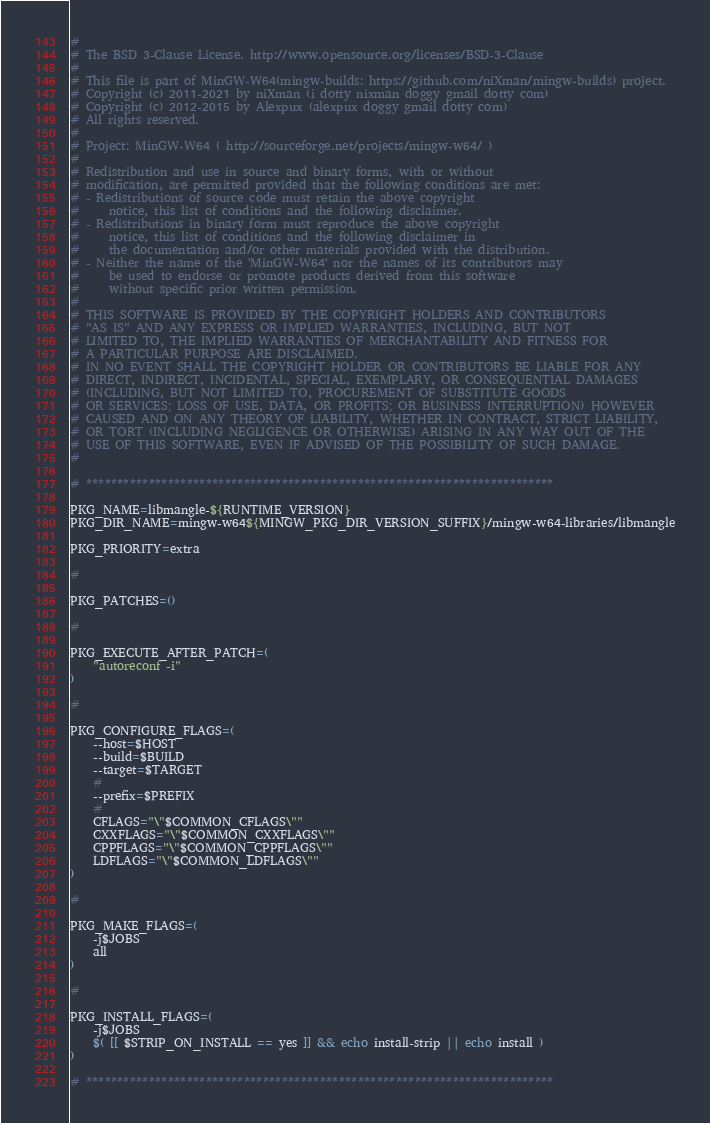Convert code to text. <code><loc_0><loc_0><loc_500><loc_500><_Bash_>
#
# The BSD 3-Clause License. http://www.opensource.org/licenses/BSD-3-Clause
#
# This file is part of MinGW-W64(mingw-builds: https://github.com/niXman/mingw-builds) project.
# Copyright (c) 2011-2021 by niXman (i dotty nixman doggy gmail dotty com)
# Copyright (c) 2012-2015 by Alexpux (alexpux doggy gmail dotty com)
# All rights reserved.
#
# Project: MinGW-W64 ( http://sourceforge.net/projects/mingw-w64/ )
#
# Redistribution and use in source and binary forms, with or without
# modification, are permitted provided that the following conditions are met:
# - Redistributions of source code must retain the above copyright
#     notice, this list of conditions and the following disclaimer.
# - Redistributions in binary form must reproduce the above copyright
#     notice, this list of conditions and the following disclaimer in
#     the documentation and/or other materials provided with the distribution.
# - Neither the name of the 'MinGW-W64' nor the names of its contributors may
#     be used to endorse or promote products derived from this software
#     without specific prior written permission.
#
# THIS SOFTWARE IS PROVIDED BY THE COPYRIGHT HOLDERS AND CONTRIBUTORS
# "AS IS" AND ANY EXPRESS OR IMPLIED WARRANTIES, INCLUDING, BUT NOT
# LIMITED TO, THE IMPLIED WARRANTIES OF MERCHANTABILITY AND FITNESS FOR
# A PARTICULAR PURPOSE ARE DISCLAIMED.
# IN NO EVENT SHALL THE COPYRIGHT HOLDER OR CONTRIBUTORS BE LIABLE FOR ANY
# DIRECT, INDIRECT, INCIDENTAL, SPECIAL, EXEMPLARY, OR CONSEQUENTIAL DAMAGES
# (INCLUDING, BUT NOT LIMITED TO, PROCUREMENT OF SUBSTITUTE GOODS
# OR SERVICES; LOSS OF USE, DATA, OR PROFITS; OR BUSINESS INTERRUPTION) HOWEVER
# CAUSED AND ON ANY THEORY OF LIABILITY, WHETHER IN CONTRACT, STRICT LIABILITY,
# OR TORT (INCLUDING NEGLIGENCE OR OTHERWISE) ARISING IN ANY WAY OUT OF THE
# USE OF THIS SOFTWARE, EVEN IF ADVISED OF THE POSSIBILITY OF SUCH DAMAGE.
#

# **************************************************************************

PKG_NAME=libmangle-${RUNTIME_VERSION}
PKG_DIR_NAME=mingw-w64${MINGW_PKG_DIR_VERSION_SUFFIX}/mingw-w64-libraries/libmangle

PKG_PRIORITY=extra

#

PKG_PATCHES=()

#

PKG_EXECUTE_AFTER_PATCH=(
	"autoreconf -i"
)

#

PKG_CONFIGURE_FLAGS=(
	--host=$HOST
	--build=$BUILD
	--target=$TARGET
	#
	--prefix=$PREFIX
	#
	CFLAGS="\"$COMMON_CFLAGS\""
	CXXFLAGS="\"$COMMON_CXXFLAGS\""
	CPPFLAGS="\"$COMMON_CPPFLAGS\""
	LDFLAGS="\"$COMMON_LDFLAGS\""
)

#

PKG_MAKE_FLAGS=(
	-j$JOBS
	all
)

#

PKG_INSTALL_FLAGS=(
	-j$JOBS
	$( [[ $STRIP_ON_INSTALL == yes ]] && echo install-strip || echo install )
)

# **************************************************************************
</code> 